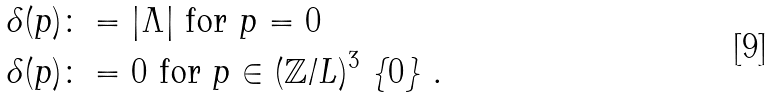<formula> <loc_0><loc_0><loc_500><loc_500>\delta ( p ) & \colon = | \Lambda | \text {  for $p=0$} \\ \delta ( p ) & \colon = 0 \text {  for $p \in (\mathbb{Z}/L)^{3}\ \{ 0\}$ .}</formula> 